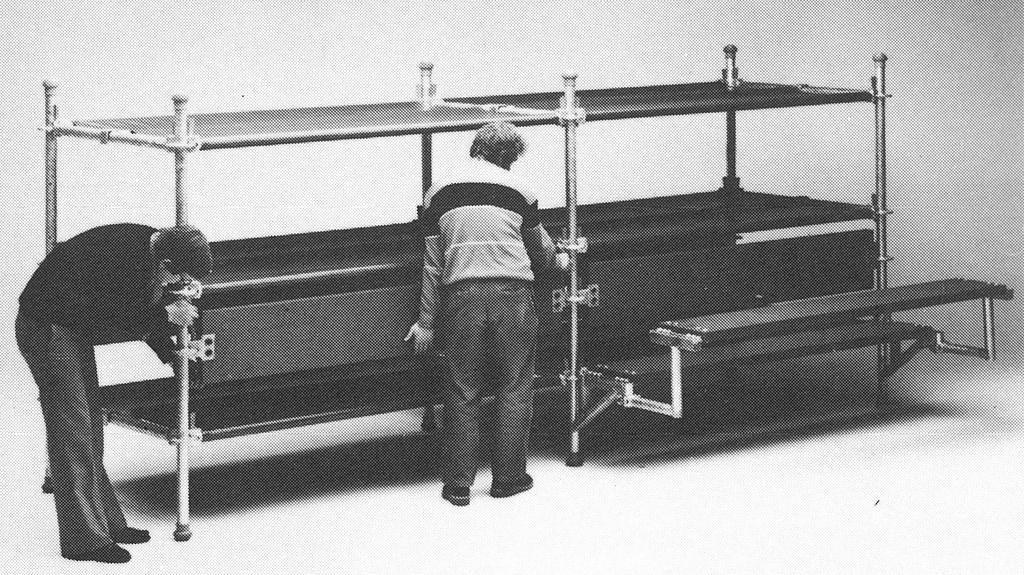Could you give a brief overview of what you see in this image? On the left side, there is a person slightly bending and holding a bunk bed along with other person who is standing and holding the bunk bed. In the background, there is white wall. 